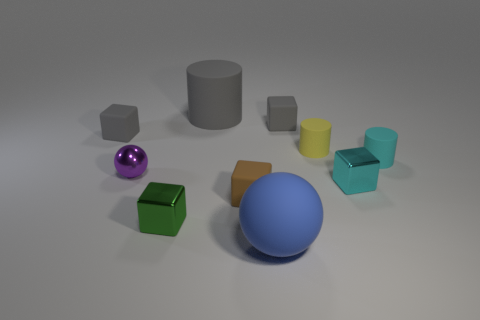What is the size of the purple ball?
Your answer should be very brief. Small. Is there a large blue thing that has the same shape as the purple metal object?
Offer a terse response. Yes. What number of large objects are either matte cylinders or gray rubber cubes?
Keep it short and to the point. 1. What number of other things are there of the same color as the tiny metal ball?
Provide a succinct answer. 0. How many other objects are made of the same material as the tiny green thing?
Keep it short and to the point. 2. There is a tiny rubber cube that is to the left of the large gray thing; does it have the same color as the large matte ball?
Provide a short and direct response. No. What number of gray things are tiny rubber cubes or metal spheres?
Keep it short and to the point. 2. Are the small gray object right of the tiny brown matte thing and the yellow cylinder made of the same material?
Offer a terse response. Yes. What number of things are either small rubber cylinders or tiny objects that are on the left side of the cyan cylinder?
Provide a succinct answer. 8. What number of large objects are behind the tiny gray cube in front of the tiny gray matte thing on the right side of the shiny ball?
Your response must be concise. 1. 